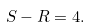<formula> <loc_0><loc_0><loc_500><loc_500>S - R = 4 .</formula> 